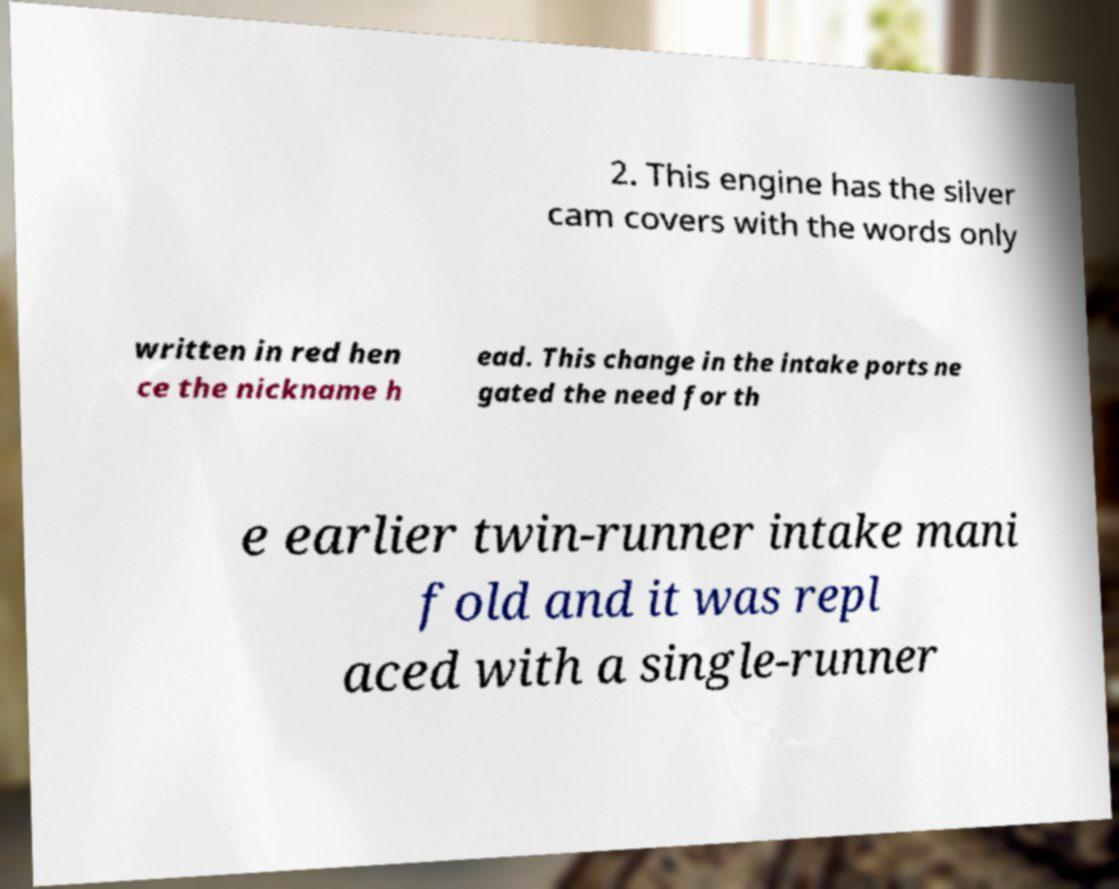Can you accurately transcribe the text from the provided image for me? 2. This engine has the silver cam covers with the words only written in red hen ce the nickname h ead. This change in the intake ports ne gated the need for th e earlier twin-runner intake mani fold and it was repl aced with a single-runner 